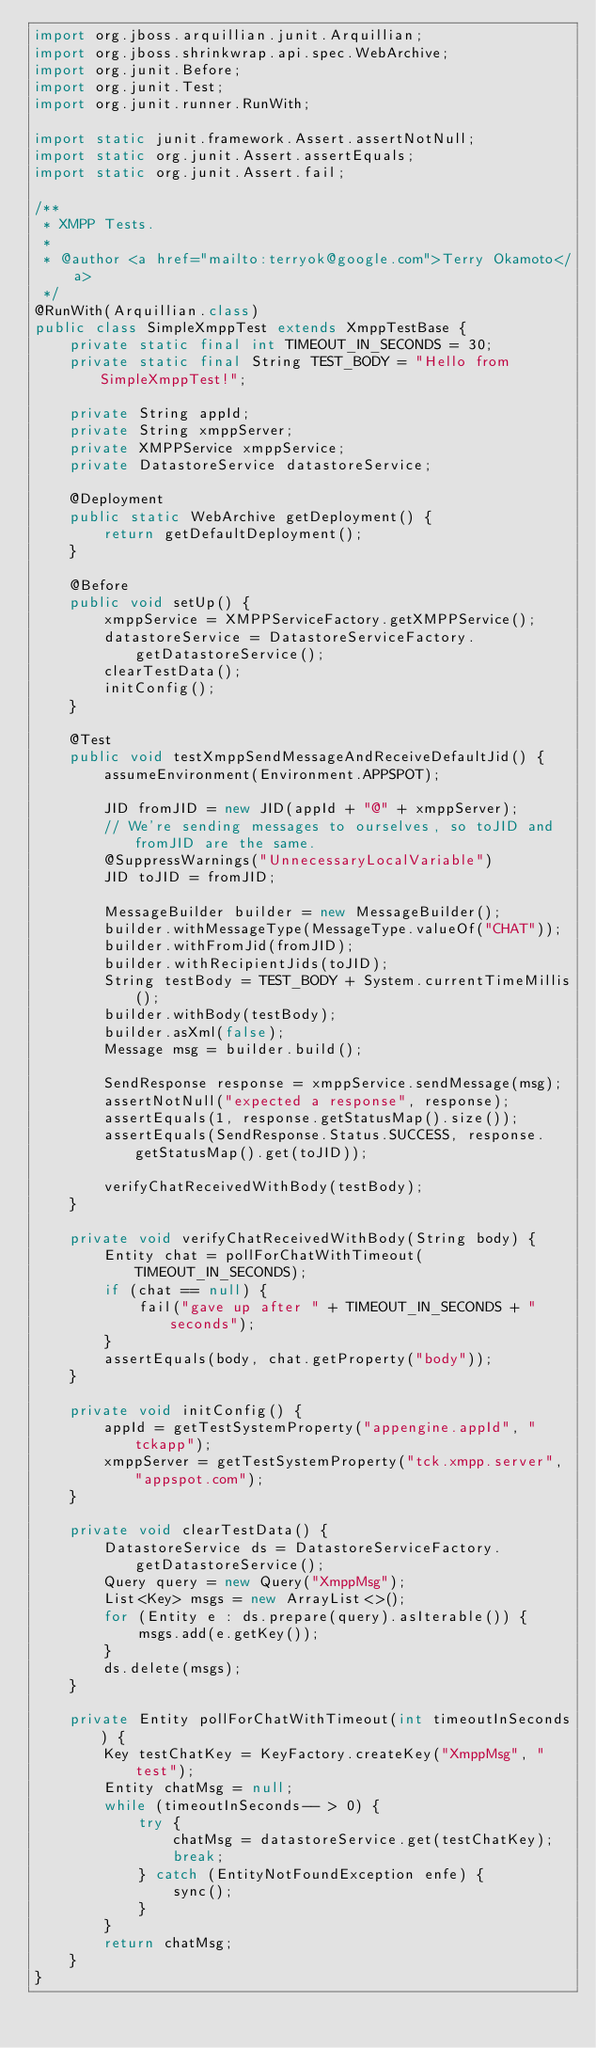Convert code to text. <code><loc_0><loc_0><loc_500><loc_500><_Java_>import org.jboss.arquillian.junit.Arquillian;
import org.jboss.shrinkwrap.api.spec.WebArchive;
import org.junit.Before;
import org.junit.Test;
import org.junit.runner.RunWith;

import static junit.framework.Assert.assertNotNull;
import static org.junit.Assert.assertEquals;
import static org.junit.Assert.fail;

/**
 * XMPP Tests.
 *
 * @author <a href="mailto:terryok@google.com">Terry Okamoto</a>
 */
@RunWith(Arquillian.class)
public class SimpleXmppTest extends XmppTestBase {
    private static final int TIMEOUT_IN_SECONDS = 30;
    private static final String TEST_BODY = "Hello from SimpleXmppTest!";

    private String appId;
    private String xmppServer;
    private XMPPService xmppService;
    private DatastoreService datastoreService;

    @Deployment
    public static WebArchive getDeployment() {
        return getDefaultDeployment();
    }

    @Before
    public void setUp() {
        xmppService = XMPPServiceFactory.getXMPPService();
        datastoreService = DatastoreServiceFactory.getDatastoreService();
        clearTestData();
        initConfig();
    }

    @Test
    public void testXmppSendMessageAndReceiveDefaultJid() {
        assumeEnvironment(Environment.APPSPOT);

        JID fromJID = new JID(appId + "@" + xmppServer);
        // We're sending messages to ourselves, so toJID and fromJID are the same.
        @SuppressWarnings("UnnecessaryLocalVariable")
        JID toJID = fromJID;

        MessageBuilder builder = new MessageBuilder();
        builder.withMessageType(MessageType.valueOf("CHAT"));
        builder.withFromJid(fromJID);
        builder.withRecipientJids(toJID);
        String testBody = TEST_BODY + System.currentTimeMillis();
        builder.withBody(testBody);
        builder.asXml(false);
        Message msg = builder.build();

        SendResponse response = xmppService.sendMessage(msg);
        assertNotNull("expected a response", response);
        assertEquals(1, response.getStatusMap().size());
        assertEquals(SendResponse.Status.SUCCESS, response.getStatusMap().get(toJID));

        verifyChatReceivedWithBody(testBody);
    }

    private void verifyChatReceivedWithBody(String body) {
        Entity chat = pollForChatWithTimeout(TIMEOUT_IN_SECONDS);
        if (chat == null) {
            fail("gave up after " + TIMEOUT_IN_SECONDS + " seconds");
        }
        assertEquals(body, chat.getProperty("body"));
    }

    private void initConfig() {
        appId = getTestSystemProperty("appengine.appId", "tckapp");
        xmppServer = getTestSystemProperty("tck.xmpp.server", "appspot.com");
    }

    private void clearTestData() {
        DatastoreService ds = DatastoreServiceFactory.getDatastoreService();
        Query query = new Query("XmppMsg");
        List<Key> msgs = new ArrayList<>();
        for (Entity e : ds.prepare(query).asIterable()) {
            msgs.add(e.getKey());
        }
        ds.delete(msgs);
    }

    private Entity pollForChatWithTimeout(int timeoutInSeconds) {
        Key testChatKey = KeyFactory.createKey("XmppMsg", "test");
        Entity chatMsg = null;
        while (timeoutInSeconds-- > 0) {
            try {
                chatMsg = datastoreService.get(testChatKey);
                break;
            } catch (EntityNotFoundException enfe) {
                sync();
            }
        }
        return chatMsg;
    }
}
</code> 